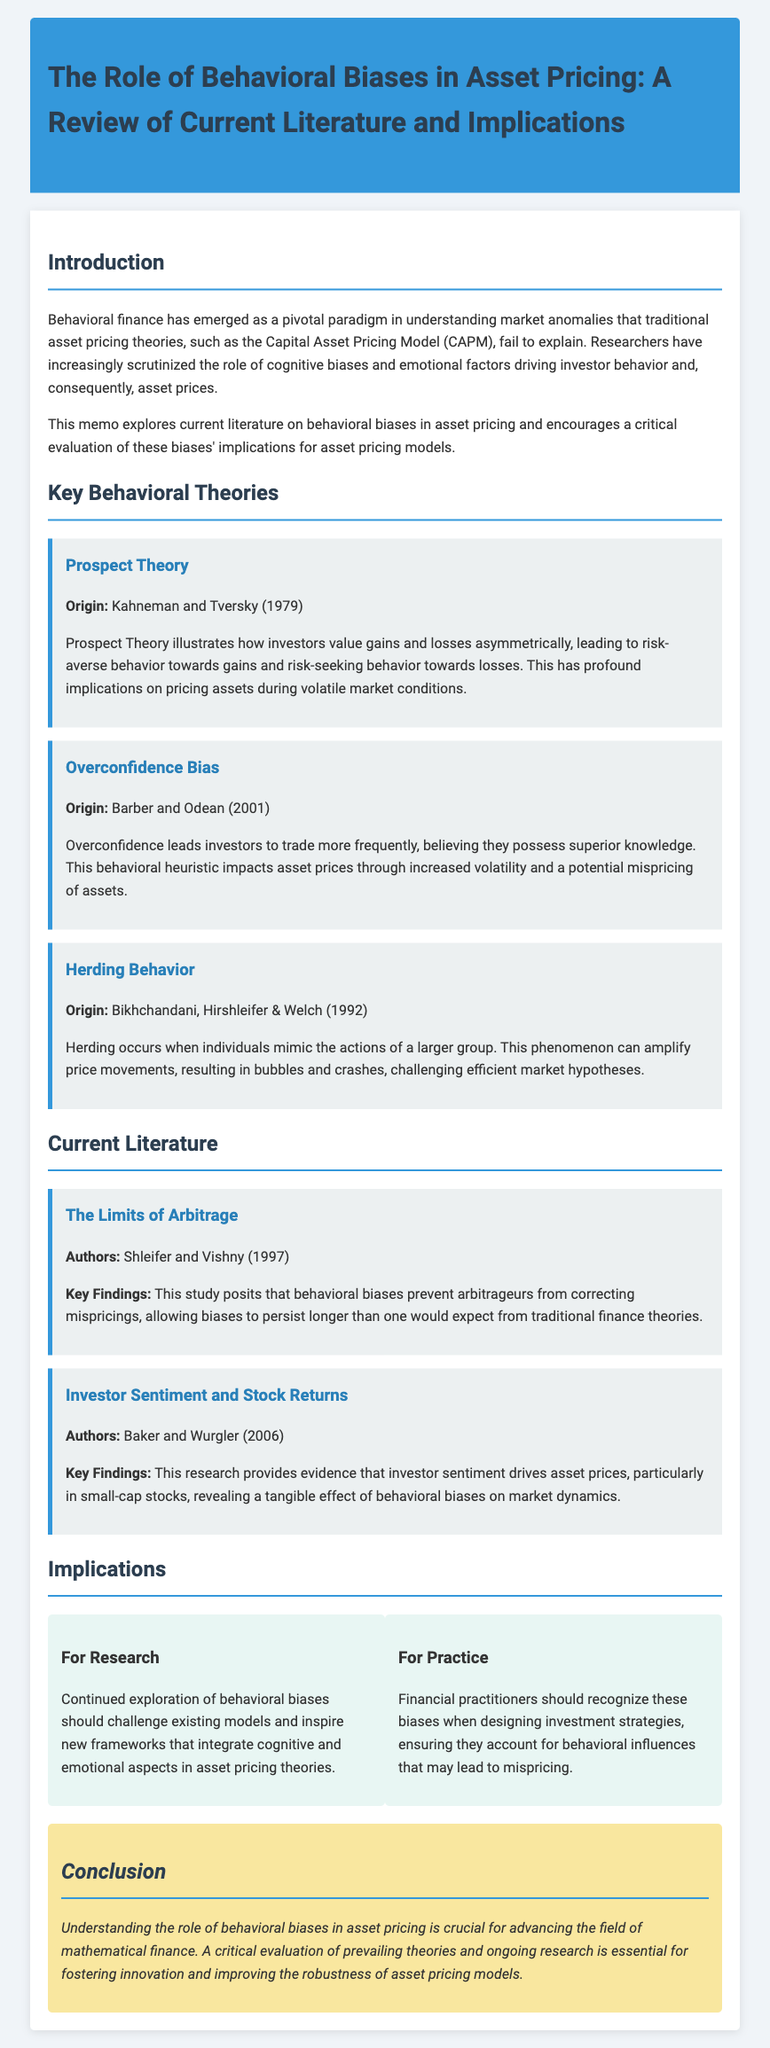What does behavioral finance help explain? Behavioral finance helps explain market anomalies that traditional asset pricing theories fail to explain.
Answer: Market anomalies Who are the authors of Prospect Theory? Prospect Theory was originally developed by Kahneman and Tversky in 1979.
Answer: Kahneman and Tversky What phenomenon does Herding Behavior describe? Herding Behavior describes when individuals mimic the actions of a larger group, affecting price movements.
Answer: Mimicking group actions What is the key finding of Baker and Wurgler's study? Baker and Wurgler's study finds that investor sentiment drives asset prices, especially in small-cap stocks.
Answer: Investor sentiment drives asset prices How should practitioners respond to behavioral biases? Practitioners should recognize these biases when designing investment strategies.
Answer: Recognize biases in strategies What is the year of publication for the study “The Limits of Arbitrage”? The study "The Limits of Arbitrage" was published in 1997.
Answer: 1997 What implicit challenge do behavioral biases pose to traditional theories? Behavioral biases challenge the efficiency of market hypotheses, showing they can distort pricing.
Answer: Efficiency of market hypotheses What is suggested for continued research on behavioral biases? Continued exploration of behavioral biases should challenge existing models and inspire new frameworks.
Answer: Challenge existing models 